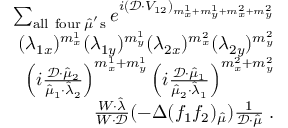<formula> <loc_0><loc_0><loc_500><loc_500>\begin{array} { r l } { \sum _ { a l l f o u r \, \hat { \mu } ^ { ^ { \prime } } s } e ^ { i ( \mathcal { D } \cdot V _ { 1 2 } ) _ { m _ { x } ^ { 1 } + m _ { y } ^ { 1 } + m _ { x } ^ { 2 } + m _ { y } ^ { 2 } } } } \\ { ( \lambda _ { 1 x } ) ^ { m _ { x } ^ { 1 } } ( \lambda _ { 1 y } ) ^ { m _ { y } ^ { 1 } } ( \lambda _ { 2 x } ) ^ { m _ { x } ^ { 2 } } ( \lambda _ { 2 y } ) ^ { m _ { y } ^ { 2 } } } \\ { \left ( i \frac { \mathcal { D } \cdot \hat { \mu } _ { 2 } } { \hat { \mu } _ { 1 } \cdot \hat { \lambda } _ { 2 } } \right ) ^ { m _ { x } ^ { 1 } + m _ { y } ^ { 1 } } \left ( i \frac { \mathcal { D } \cdot \hat { \mu } _ { 1 } } { \hat { \mu } _ { 2 } \cdot \hat { \lambda } _ { 1 } } \right ) ^ { m _ { x } ^ { 2 } + m _ { y } ^ { 2 } } } \\ { \frac { W \cdot \hat { \lambda } } { W \cdot \mathcal { D } } ( - \Delta ( f _ { 1 } f _ { 2 } ) _ { \hat { \mu } } ) \frac { 1 } { \mathcal { D } \cdot \hat { \mu } } \, . } \end{array}</formula> 